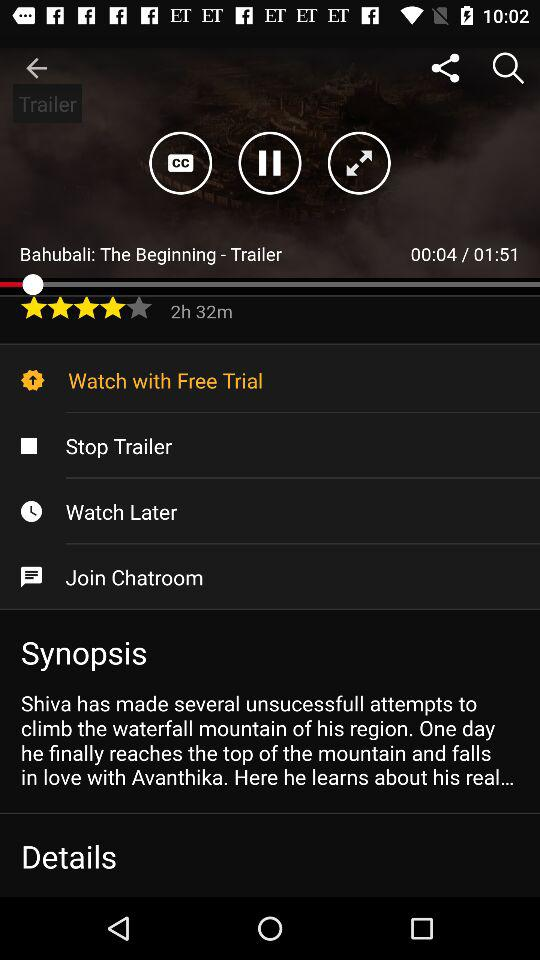How long is the movie? The movie is 2 hours and 32 minutes long. 